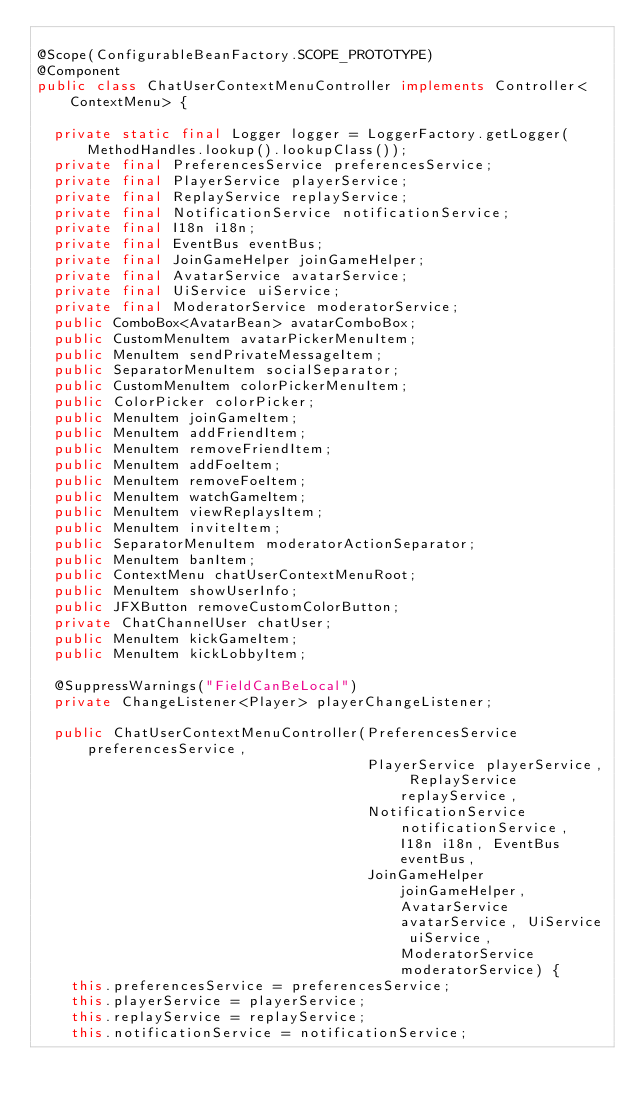<code> <loc_0><loc_0><loc_500><loc_500><_Java_>
@Scope(ConfigurableBeanFactory.SCOPE_PROTOTYPE)
@Component
public class ChatUserContextMenuController implements Controller<ContextMenu> {

  private static final Logger logger = LoggerFactory.getLogger(MethodHandles.lookup().lookupClass());
  private final PreferencesService preferencesService;
  private final PlayerService playerService;
  private final ReplayService replayService;
  private final NotificationService notificationService;
  private final I18n i18n;
  private final EventBus eventBus;
  private final JoinGameHelper joinGameHelper;
  private final AvatarService avatarService;
  private final UiService uiService;
  private final ModeratorService moderatorService;
  public ComboBox<AvatarBean> avatarComboBox;
  public CustomMenuItem avatarPickerMenuItem;
  public MenuItem sendPrivateMessageItem;
  public SeparatorMenuItem socialSeparator;
  public CustomMenuItem colorPickerMenuItem;
  public ColorPicker colorPicker;
  public MenuItem joinGameItem;
  public MenuItem addFriendItem;
  public MenuItem removeFriendItem;
  public MenuItem addFoeItem;
  public MenuItem removeFoeItem;
  public MenuItem watchGameItem;
  public MenuItem viewReplaysItem;
  public MenuItem inviteItem;
  public SeparatorMenuItem moderatorActionSeparator;
  public MenuItem banItem;
  public ContextMenu chatUserContextMenuRoot;
  public MenuItem showUserInfo;
  public JFXButton removeCustomColorButton;
  private ChatChannelUser chatUser;
  public MenuItem kickGameItem;
  public MenuItem kickLobbyItem;

  @SuppressWarnings("FieldCanBeLocal")
  private ChangeListener<Player> playerChangeListener;

  public ChatUserContextMenuController(PreferencesService preferencesService,
                                       PlayerService playerService, ReplayService replayService,
                                       NotificationService notificationService, I18n i18n, EventBus eventBus,
                                       JoinGameHelper joinGameHelper, AvatarService avatarService, UiService uiService, ModeratorService moderatorService) {
    this.preferencesService = preferencesService;
    this.playerService = playerService;
    this.replayService = replayService;
    this.notificationService = notificationService;</code> 